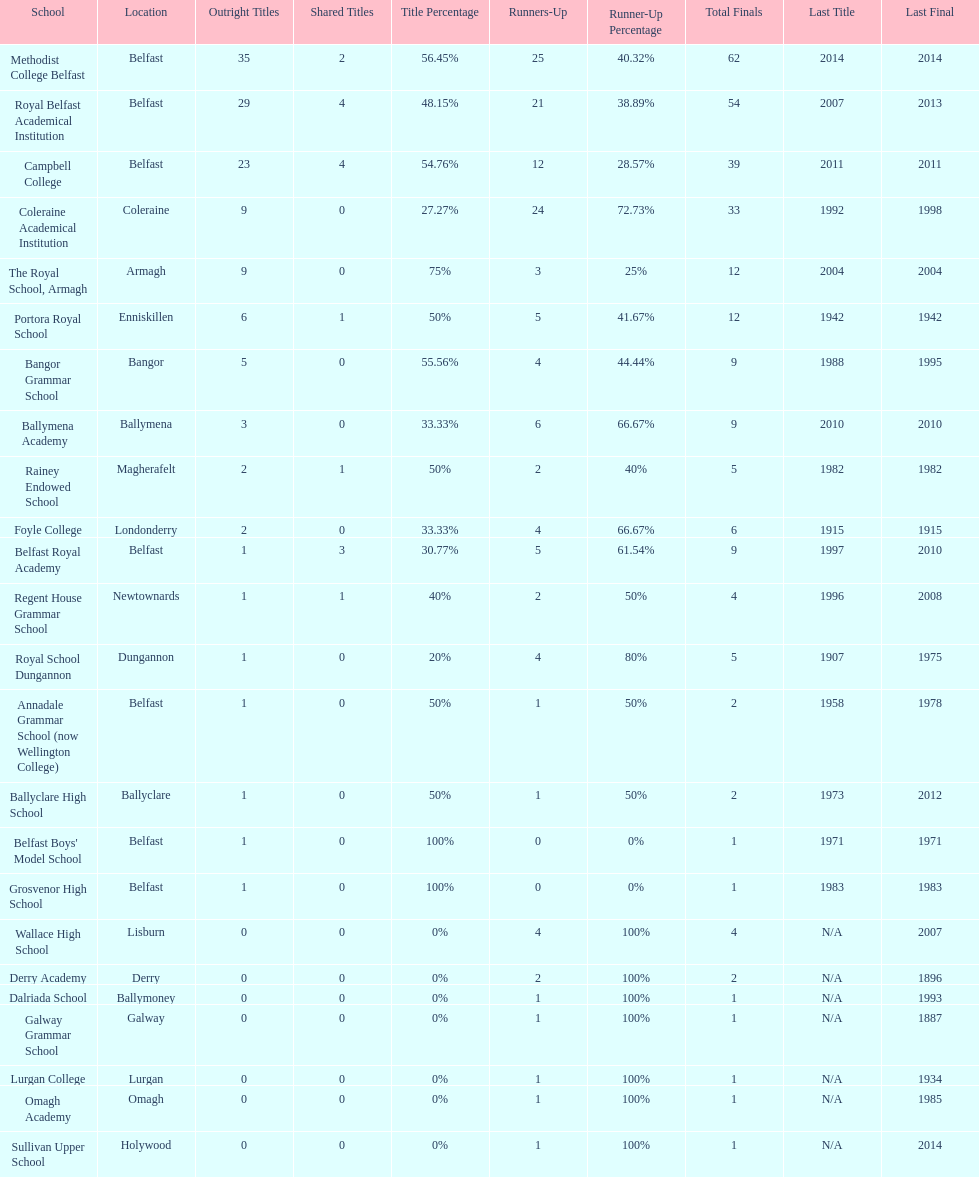How many schools had above 5 outright titles? 6. 